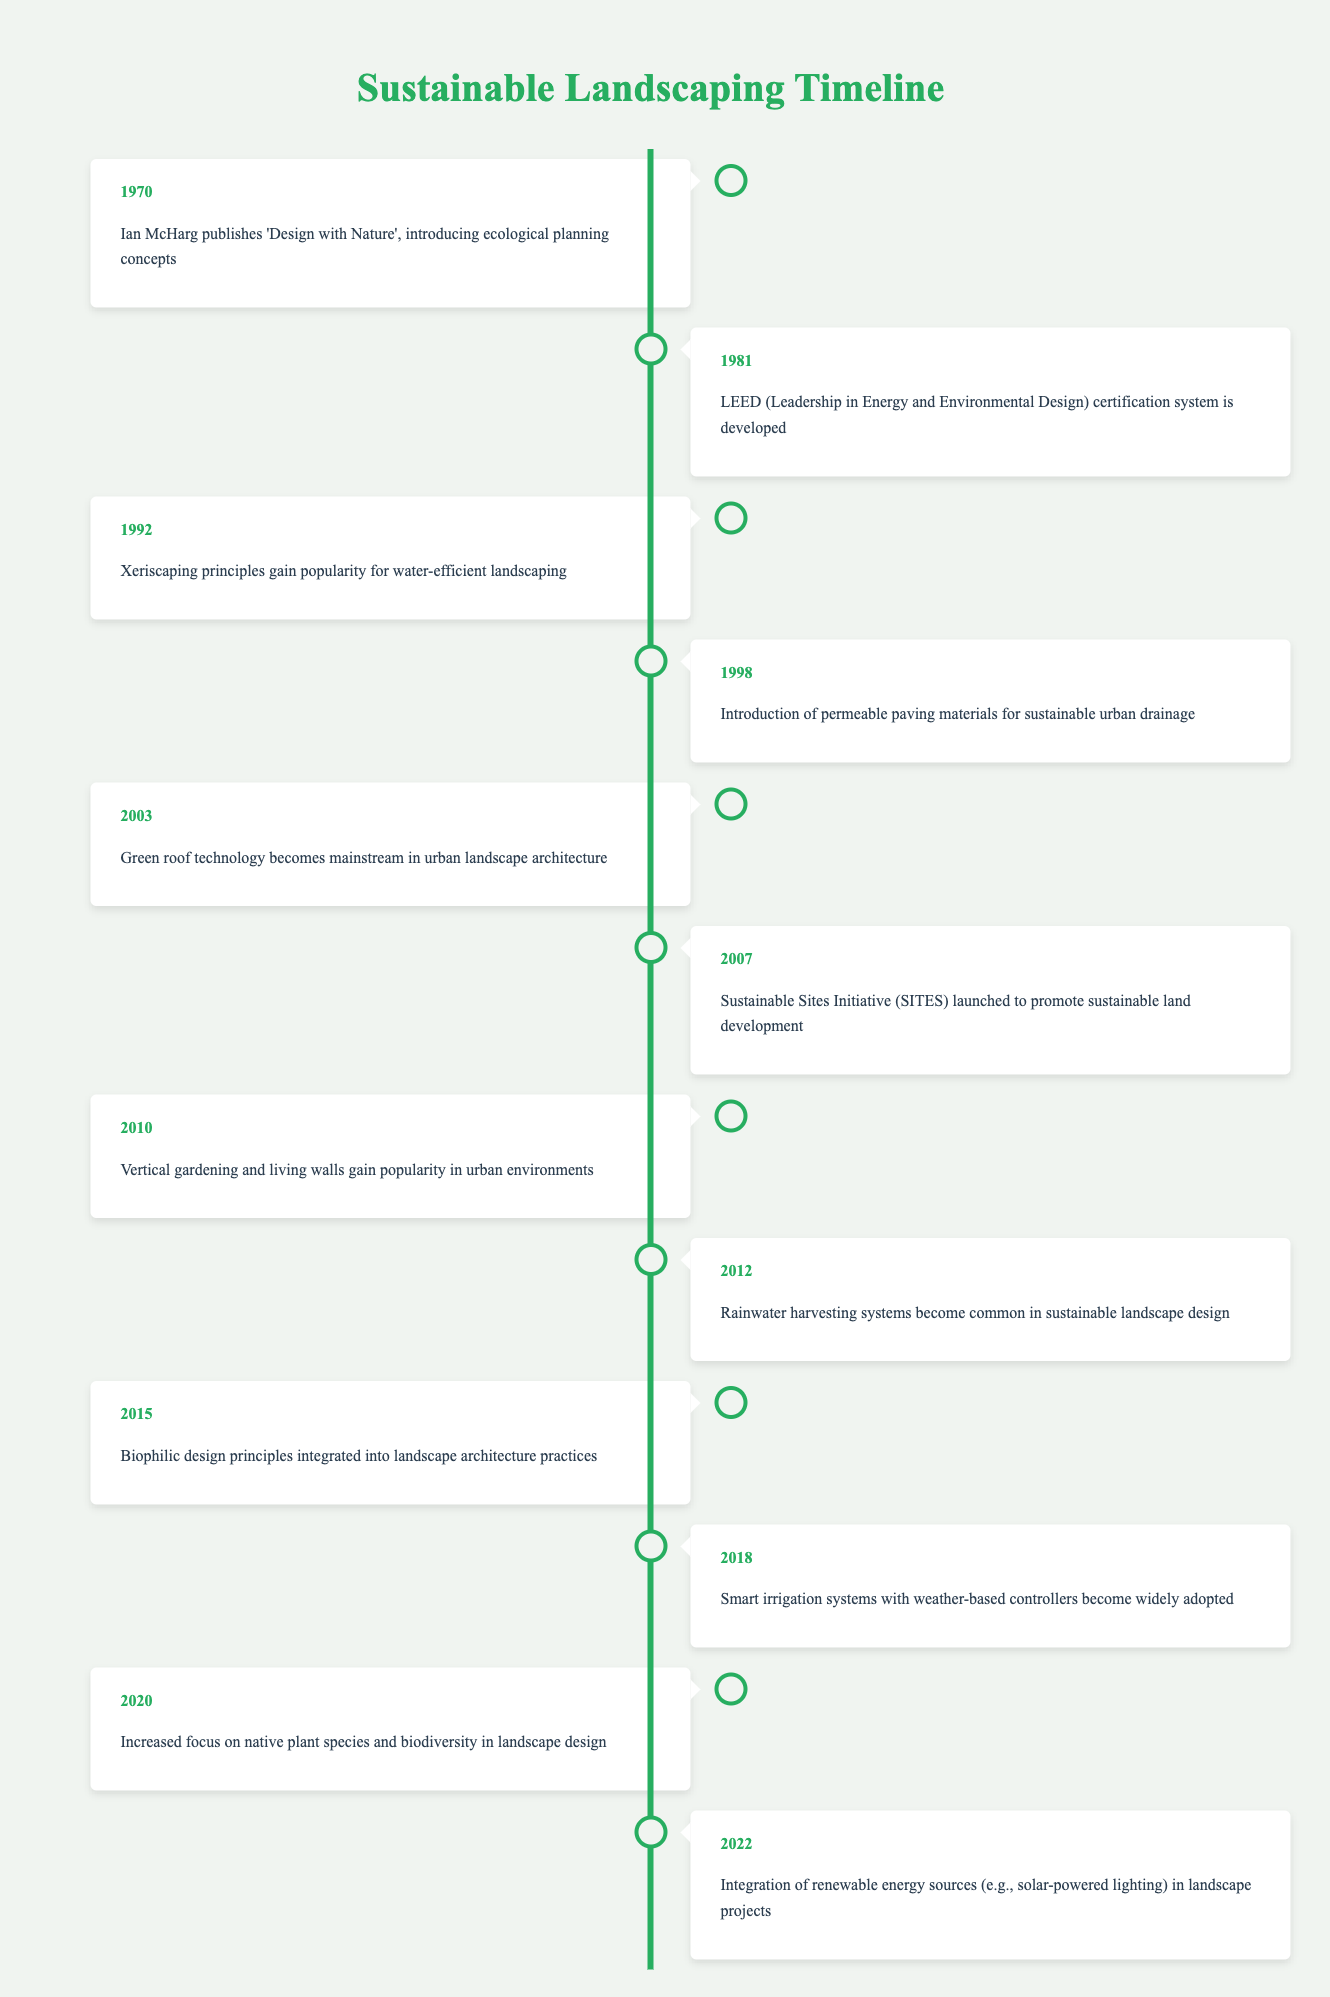What event marked the beginning of sustainable landscaping practices? The first event in the timeline is from the year 1970, where Ian McHarg published "Design with Nature," which introduced ecological planning concepts as a starting point for sustainable landscaping practices.
Answer: 1970 What year did xeriscaping principles gain popularity? According to the timeline, xeriscaping principles, which emphasize water-efficient landscaping, gained popularity in 1992.
Answer: 1992 How many events were recorded between 2000 and 2020? From the timeline, there are seven recorded events from the year 2000 to 2020. They are from 2003 to 2022, which includes the years 2003, 2007, 2010, 2012, 2015, 2018, and 2020.
Answer: 7 Was the LEED certification system developed before or after the introduction of permeable paving materials? The timeline indicates that the LEED certification system was developed in 1981 and the introduction of permeable paving materials occurred in 1998, which means LEED was developed before permeable paving.
Answer: Before What significant shift occurred in sustainable landscaping around 2015? In 2015, the timeline highlights the integration of biophilic design principles into landscape architecture practices, signifying an important shift towards incorporating natural elements to enhance well-being.
Answer: Integration of biophilic design principles What was the average year when significant sustainable landscaping events occurred based on the timeline? To find the average, first sum the years of all the events: (1970 + 1981 + 1992 + 1998 + 2003 + 2007 + 2010 + 2012 + 2015 + 2018 + 2020 + 2022) = 23659. There are 12 events, so the average year is 23659 / 12 = 1971.58, rounding to 1972.
Answer: 1972 How many times is the concept of water efficiency mentioned in the timeline? Water efficiency is mentioned specifically in two events: 1992 with xeriscaping principles gaining popularity and 2018 with smart irrigation systems becoming widely adopted.
Answer: 2 times What year marked the mainstream adoption of green roof technology? The timeline shows that green roof technology became mainstream in the year 2003.
Answer: 2003 